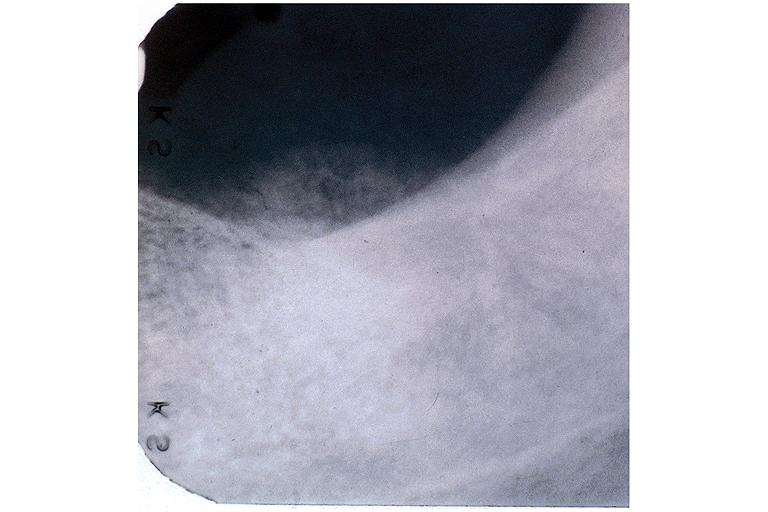where is this?
Answer the question using a single word or phrase. Oral 